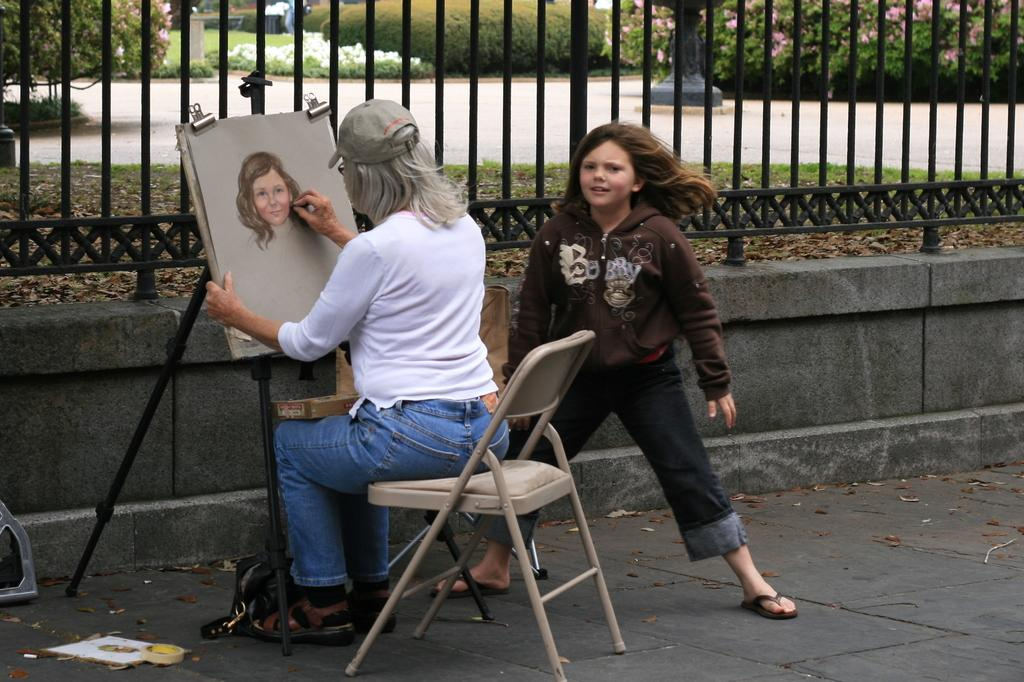What type of natural elements can be seen in the image? There are trees in the image. What type of man-made structure is visible in the image? There is a road and a fence in the image. How many people are present in the image? There are two persons in the image. What is the woman in the image doing? The woman is sitting on a chair and drawing on a board. What is the woman wearing on her head? The woman is wearing a cap. What type of basket can be seen on the scale in the image? There is no basket or scale present in the image. What is the woman using to start a fire in the image? There is no fire or fire-starting tool present in the image. 